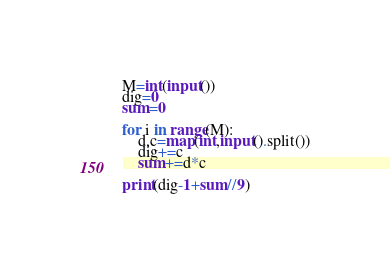<code> <loc_0><loc_0><loc_500><loc_500><_Python_>M=int(input())
dig=0
sum=0

for i in range(M):
    d,c=map(int,input().split())
    dig+=c
    sum+=d*c
    
print(dig-1+sum//9)</code> 